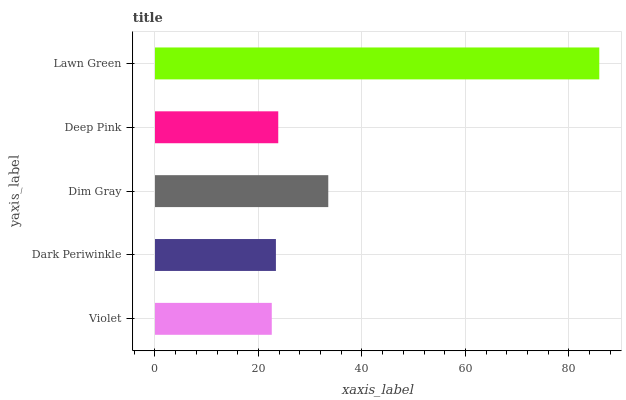Is Violet the minimum?
Answer yes or no. Yes. Is Lawn Green the maximum?
Answer yes or no. Yes. Is Dark Periwinkle the minimum?
Answer yes or no. No. Is Dark Periwinkle the maximum?
Answer yes or no. No. Is Dark Periwinkle greater than Violet?
Answer yes or no. Yes. Is Violet less than Dark Periwinkle?
Answer yes or no. Yes. Is Violet greater than Dark Periwinkle?
Answer yes or no. No. Is Dark Periwinkle less than Violet?
Answer yes or no. No. Is Deep Pink the high median?
Answer yes or no. Yes. Is Deep Pink the low median?
Answer yes or no. Yes. Is Dark Periwinkle the high median?
Answer yes or no. No. Is Dim Gray the low median?
Answer yes or no. No. 